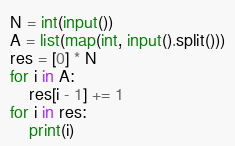Convert code to text. <code><loc_0><loc_0><loc_500><loc_500><_Python_>N = int(input())
A = list(map(int, input().split()))
res = [0] * N
for i in A:
    res[i - 1] += 1
for i in res:
    print(i)</code> 